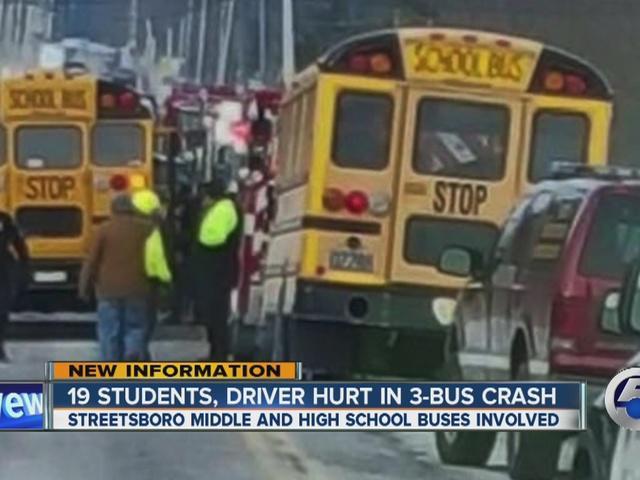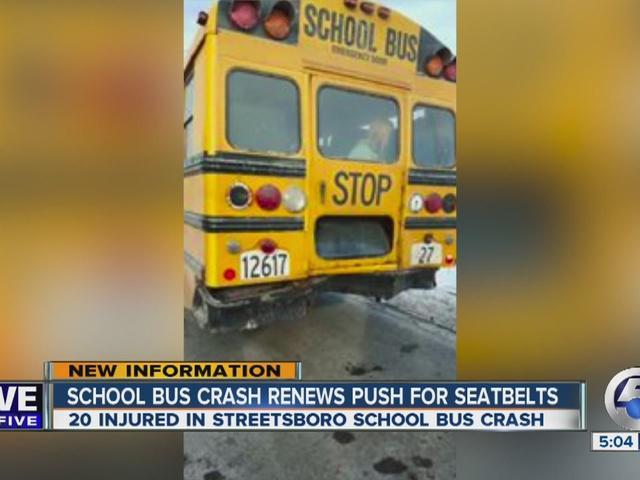The first image is the image on the left, the second image is the image on the right. Examine the images to the left and right. Is the description "News headline is visible at bottom of photo for at least one image." accurate? Answer yes or no. Yes. The first image is the image on the left, the second image is the image on the right. For the images shown, is this caption "There is 2 school busses shown." true? Answer yes or no. No. 